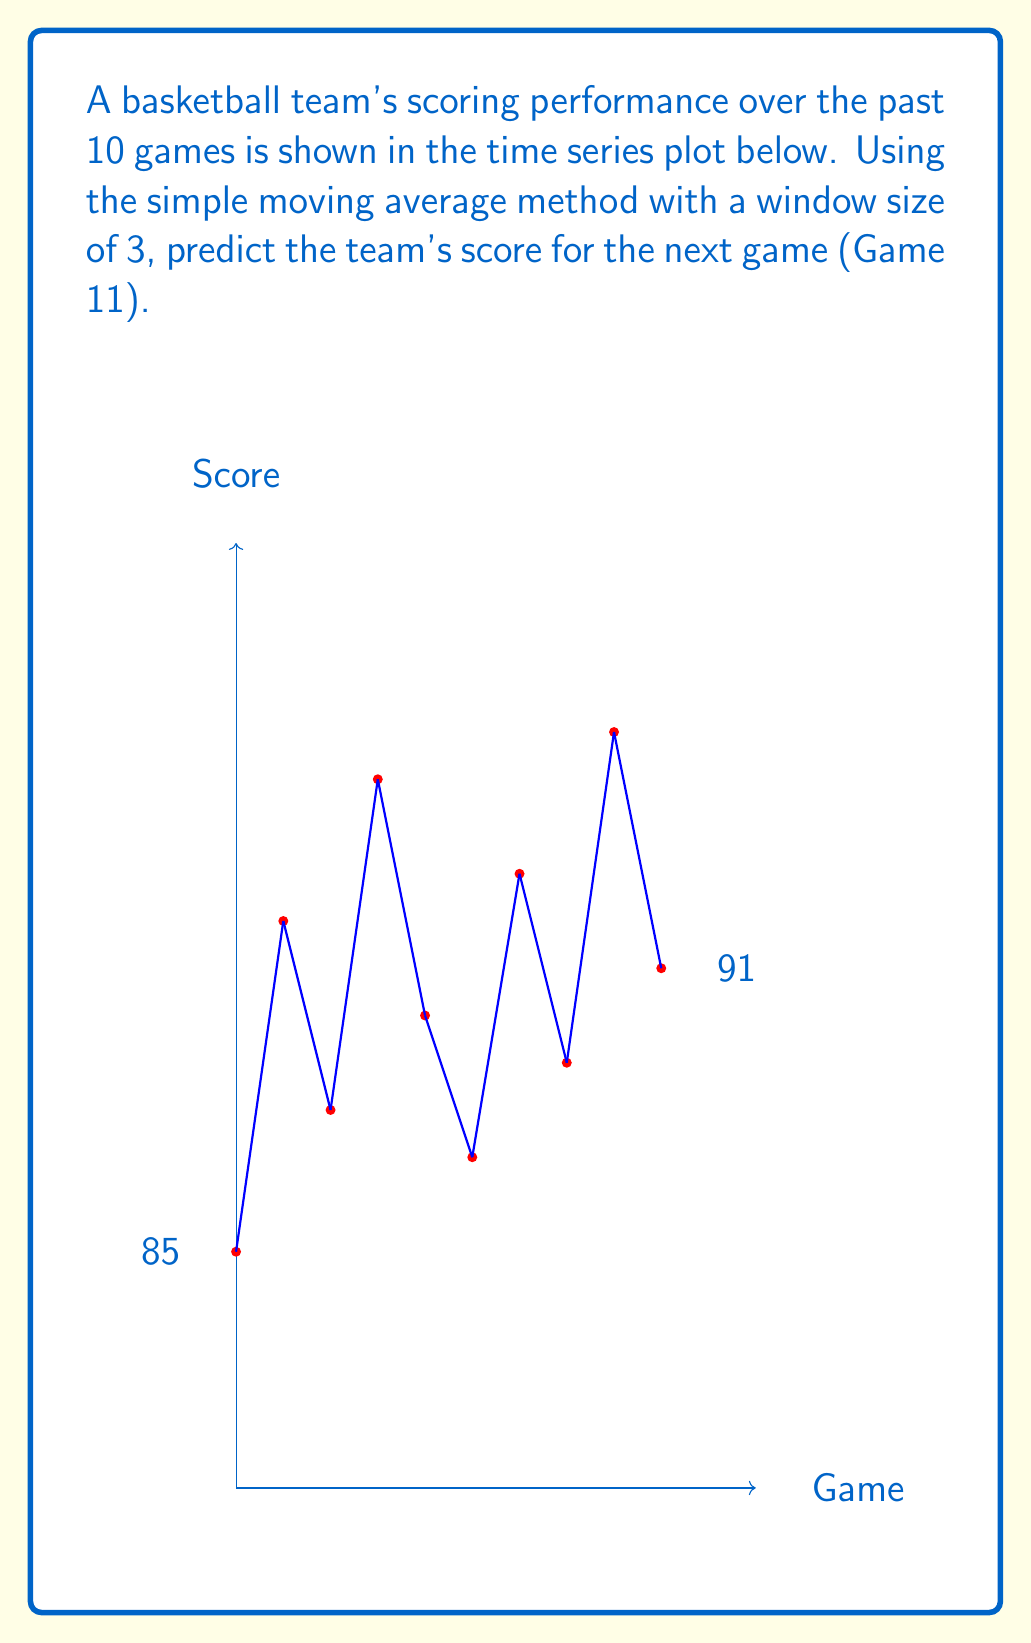Solve this math problem. To predict the team's score for Game 11 using a simple moving average with a window size of 3, we'll follow these steps:

1) First, let's recall that a simple moving average is calculated by taking the average of the most recent n data points, where n is the window size. In this case, n = 3.

2) We need to focus on the scores from the last 3 games (Games 8, 9, and 10):
   Game 8: 89
   Game 9: 96
   Game 10: 91

3) Calculate the average of these three scores:

   $$ SMA = \frac{89 + 96 + 91}{3} = \frac{276}{3} = 92 $$

4) Therefore, our prediction for Game 11 is 92 points.

This method assumes that recent performance is a good indicator of future performance, which is often a reasonable assumption in sports analytics. However, it's important to note that this is a simple model and doesn't account for factors like injuries, player trades, or changes in team strategy.
Answer: 92 points 